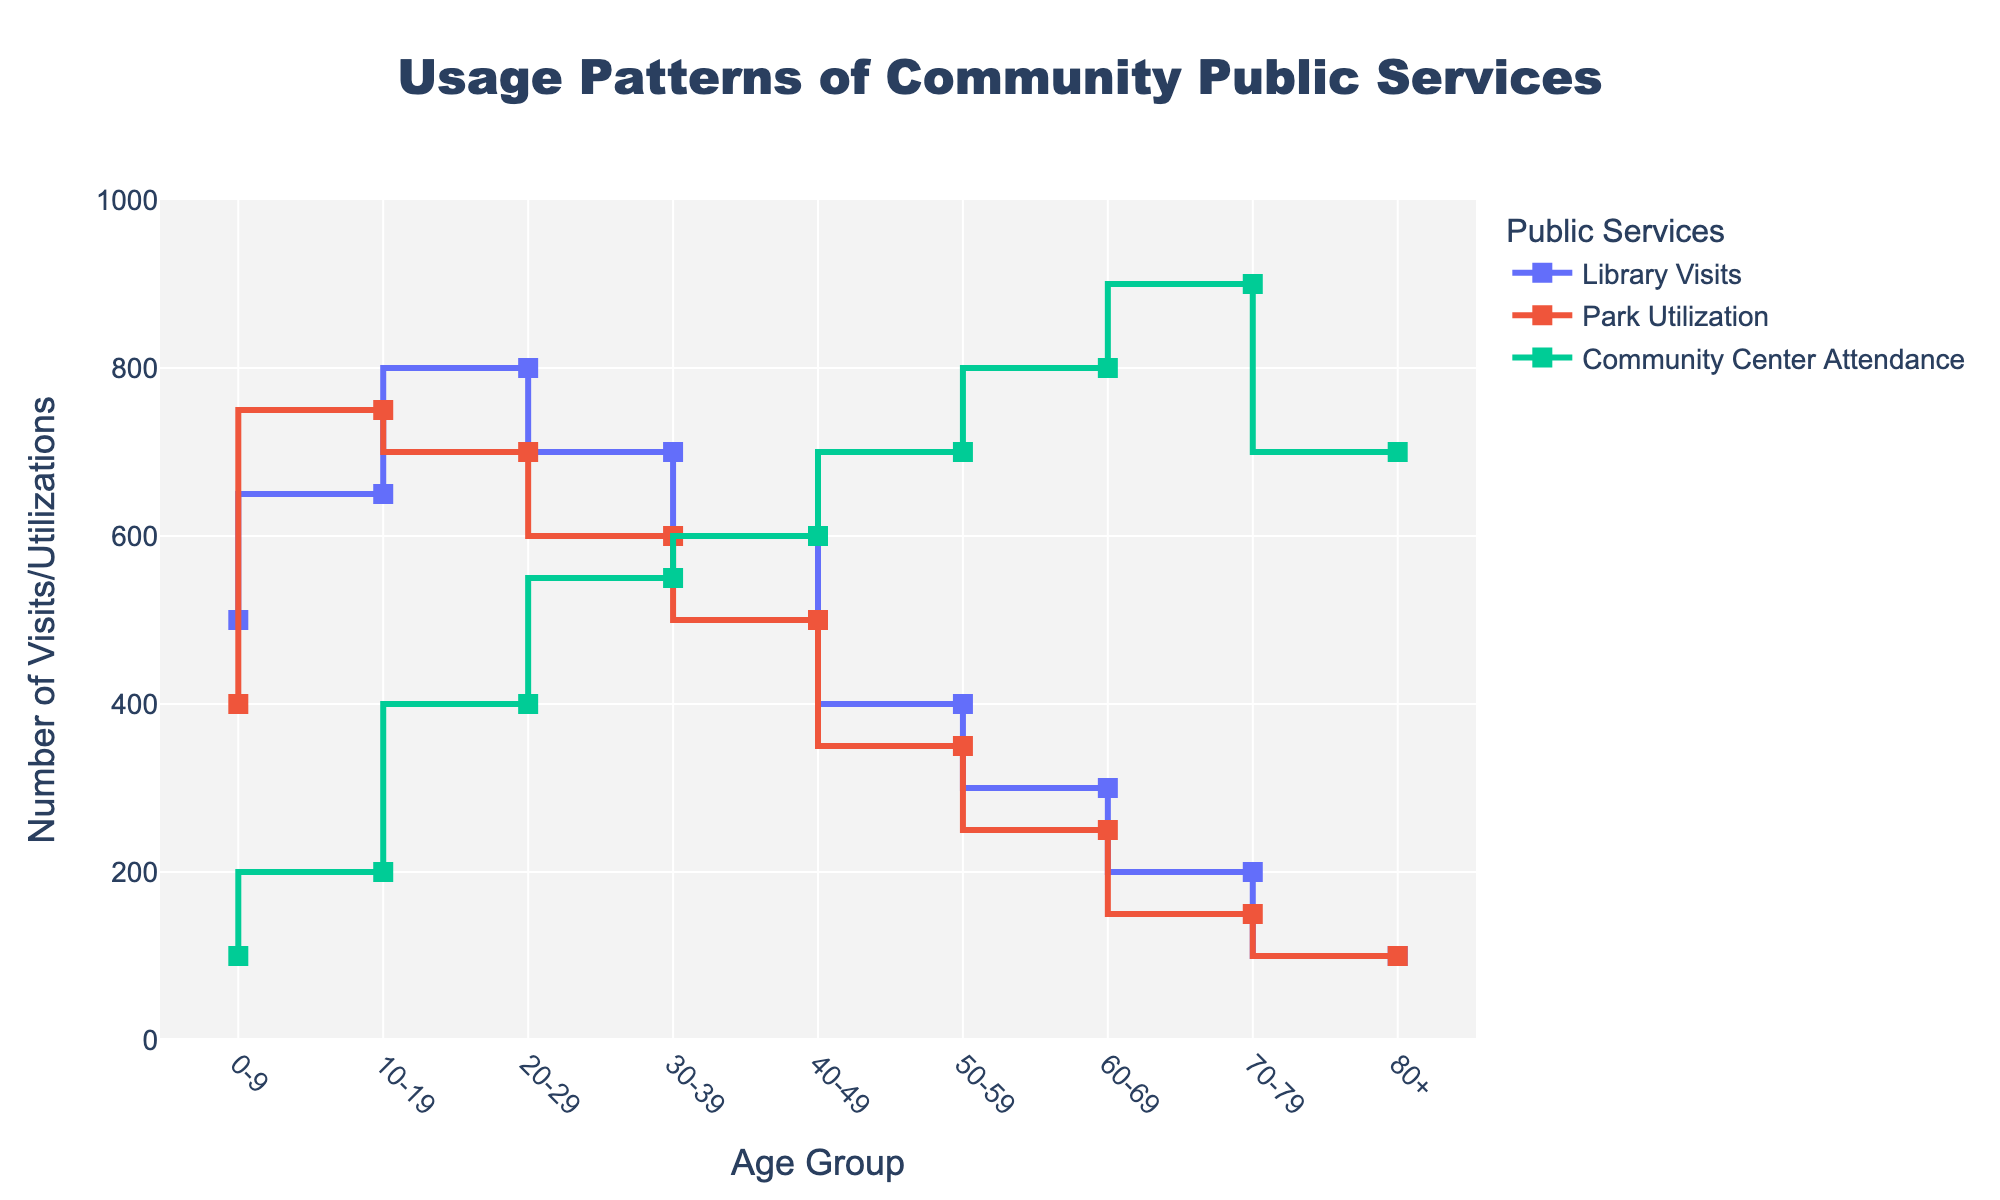what is the title of the plot? The title is usually written in a larger and bolder font at the top of the plot. In the figure, the title is centered and it reads "Usage Patterns of Community Public Services".
Answer: Usage Patterns of Community Public Services what is the x-axis representing? The x-axis label is displayed below the horizontal line at the bottom of the plot. For this figure, it reads "Age Group".
Answer: Age Group which age group has the highest number of park utilizations? Look at the line representing Park Utilization and find the highest point. The highest number corresponds to the age group 10-19.
Answer: 10-19 what is the pattern of community center attendance for people aged 60-69? Look at the line representing Community Center Attendance. For the age group 60-69, the number of visits is 800.
Answer: 800 how do library visits compare between age groups 20-29 and 50-59? Find the points on the Library Visits line for both age groups. For age group 20-29, there are 800 visits. For age group 50-59, there are 400 visits. By comparing these values, age group 20-29 has more library visits.
Answer: 20-29 has more which public service shows a steady increase in utilization with increasing age? Look at the three lines and identify the one that generally trends upwards. Community Center Attendance increases steadily with age.
Answer: Community Center Attendance what is the sum of park utilization for age groups 30-39 and 40-49? Find the values of Park Utilization for both age groups. For 30-39, it's 600 and for 40-49, it's 500. Adding these gives 600 + 500 = 1100.
Answer: 1100 which age group has the least usage of library services? Look at the line representing Library Visits and find the lowest point. The age group 80+ has the least library visits with 100.
Answer: 80+ what is the average community center attendance from age groups 70-79 and 80+? Find the values for Community Center Attendance for both age groups. 70-79 has 900, and 80+ has 700. Their average is (900 + 700) / 2 = 800.
Answer: 800 